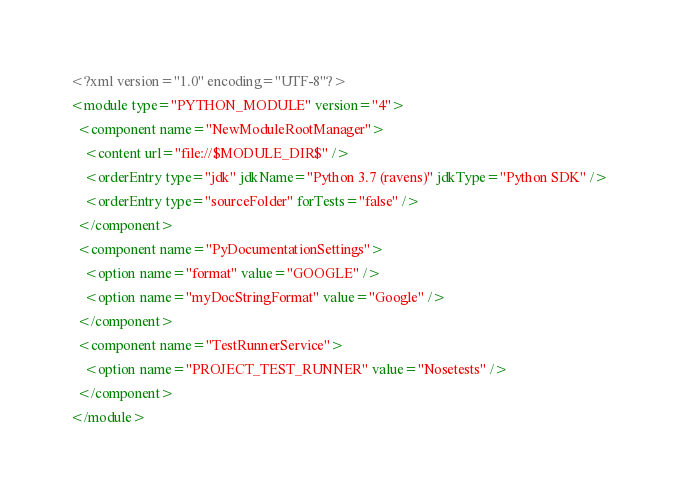<code> <loc_0><loc_0><loc_500><loc_500><_XML_><?xml version="1.0" encoding="UTF-8"?>
<module type="PYTHON_MODULE" version="4">
  <component name="NewModuleRootManager">
    <content url="file://$MODULE_DIR$" />
    <orderEntry type="jdk" jdkName="Python 3.7 (ravens)" jdkType="Python SDK" />
    <orderEntry type="sourceFolder" forTests="false" />
  </component>
  <component name="PyDocumentationSettings">
    <option name="format" value="GOOGLE" />
    <option name="myDocStringFormat" value="Google" />
  </component>
  <component name="TestRunnerService">
    <option name="PROJECT_TEST_RUNNER" value="Nosetests" />
  </component>
</module></code> 